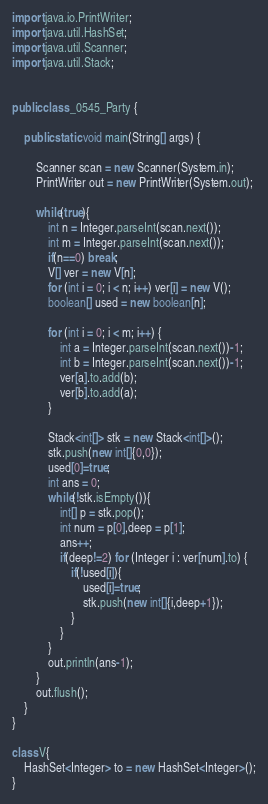<code> <loc_0><loc_0><loc_500><loc_500><_Java_>import java.io.PrintWriter;
import java.util.HashSet;
import java.util.Scanner;
import java.util.Stack;


public class _0545_Party {

	public static void main(String[] args) {

		Scanner scan = new Scanner(System.in);
		PrintWriter out = new PrintWriter(System.out);

		while(true){
			int n = Integer.parseInt(scan.next());
			int m = Integer.parseInt(scan.next());
			if(n==0) break;
			V[] ver = new V[n];
			for (int i = 0; i < n; i++) ver[i] = new V();
			boolean[] used = new boolean[n];

			for (int i = 0; i < m; i++) {
				int a = Integer.parseInt(scan.next())-1;
				int b = Integer.parseInt(scan.next())-1;
				ver[a].to.add(b);
				ver[b].to.add(a);
			}

			Stack<int[]> stk = new Stack<int[]>();
			stk.push(new int[]{0,0});
			used[0]=true;
			int ans = 0;
			while(!stk.isEmpty()){
				int[] p = stk.pop();
				int num = p[0],deep = p[1];
				ans++;
				if(deep!=2) for (Integer i : ver[num].to) {
					if(!used[i]){
						used[i]=true;
						stk.push(new int[]{i,deep+1});
					}
				}
			}
			out.println(ans-1);
		}
		out.flush();
	}
}

class V{
	HashSet<Integer> to = new HashSet<Integer>();
}</code> 